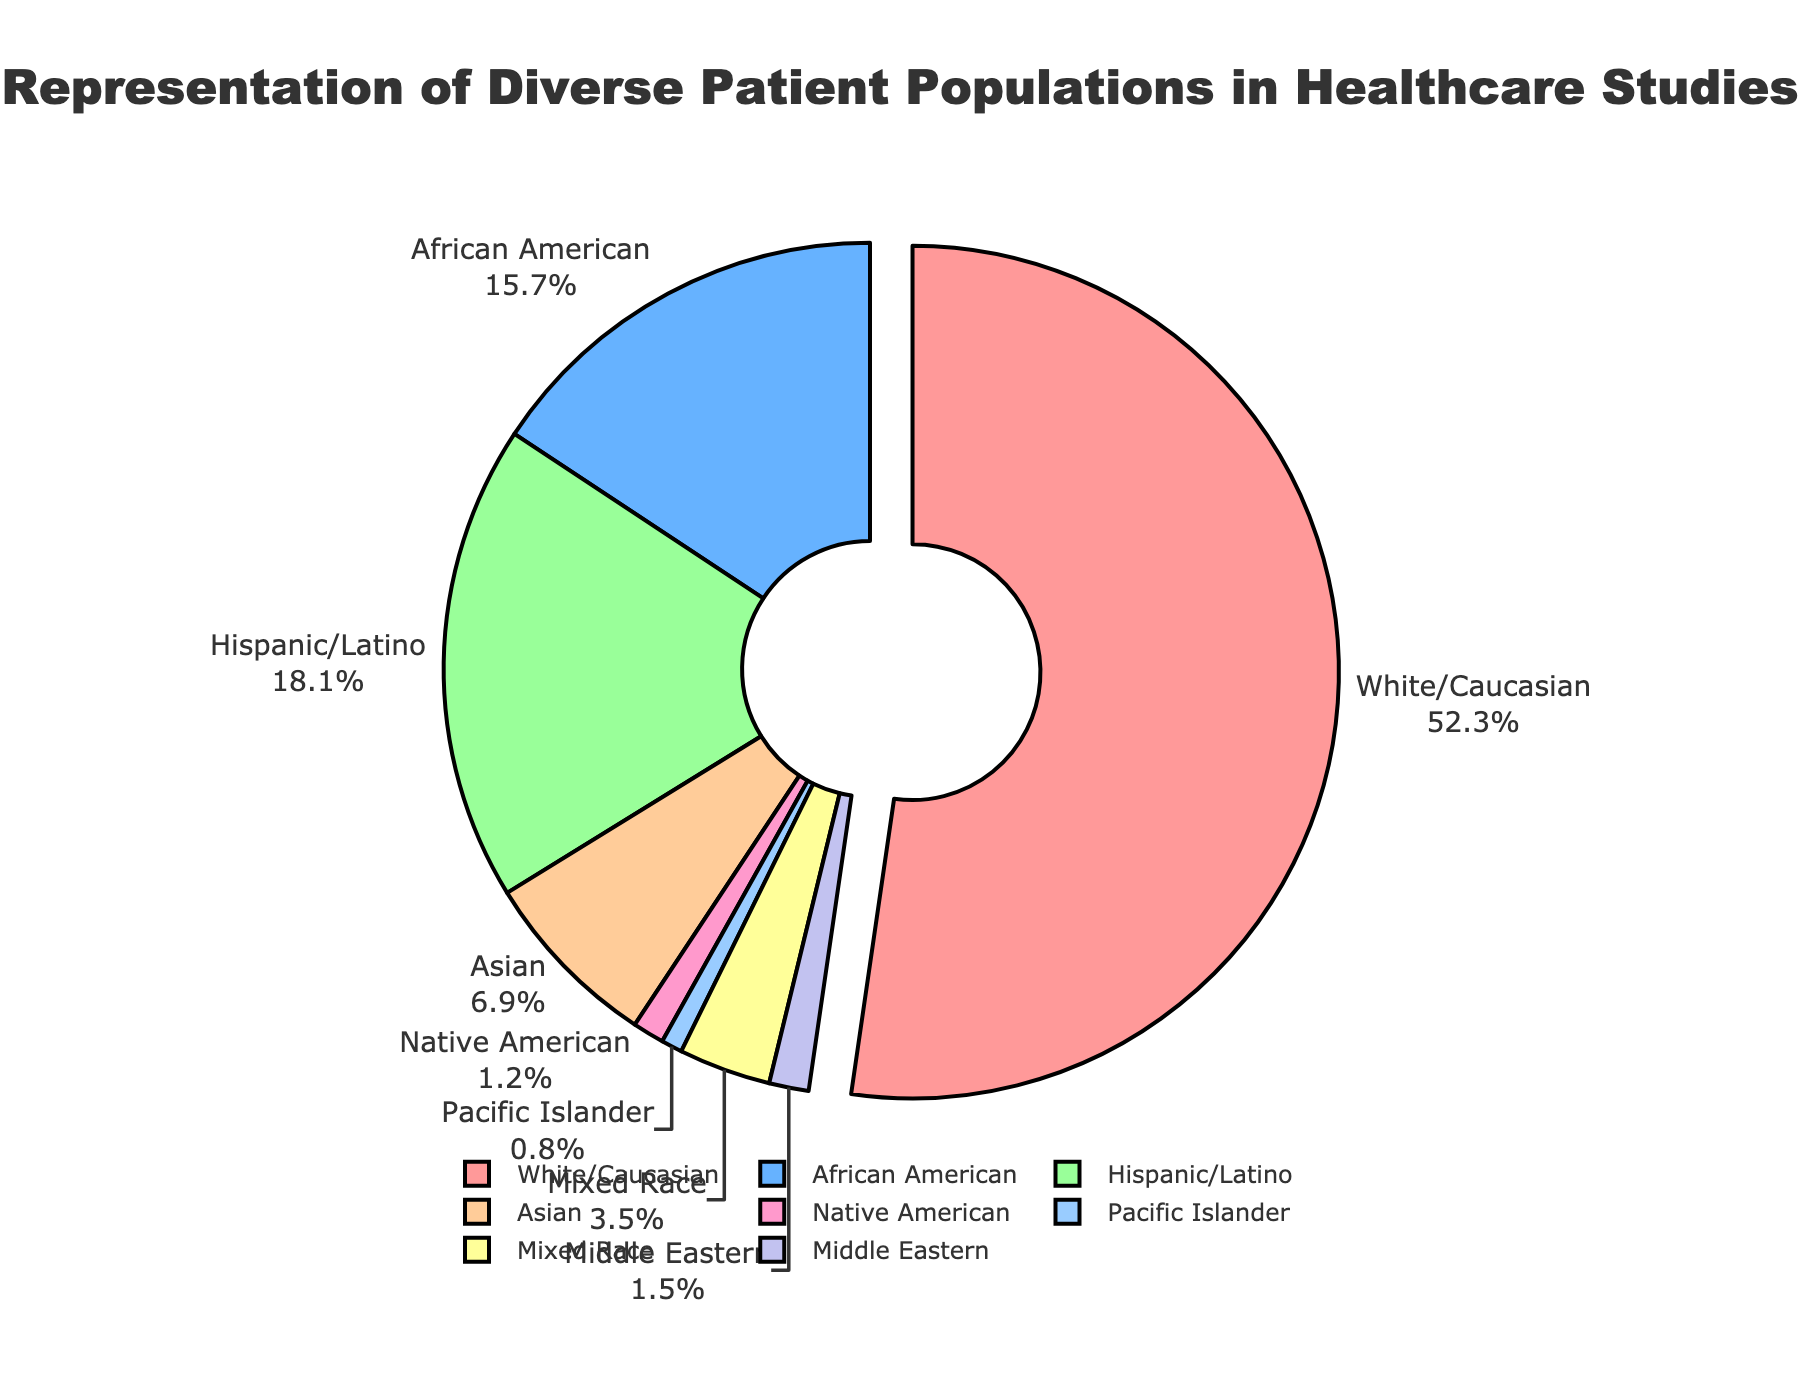What ethnicity has the highest representation in healthcare studies? The ethnicity with the highest percentage in the pie chart is White/Caucasian.
Answer: White/Caucasian What is the combined percentage of Hispanic/Latino and African American populations? The percentages for Hispanic/Latino and African American are 18.1% and 15.7%, respectively. Combined, this is 18.1 + 15.7 = 33.8%.
Answer: 33.8% Which ethnicity has the smallest representation and what is its percentage? The ethnicity with the smallest percentage in the pie chart is Pacific Islander with 0.8%.
Answer: Pacific Islander (0.8%) What is the percentage difference between Whites/Caucasians and Asians? The percentage for Whites/Caucasians is 52.3%, and for Asians, it is 6.9%. The difference is 52.3 - 6.9 = 45.4%.
Answer: 45.4% How many ethnicities have a representation of less than 5%? The ethnicities with representation less than 5% are Native American (1.2%), Pacific Islander (0.8%), Mixed Race (3.5%), and Middle Eastern (1.5%). There are 4 such ethnicities.
Answer: 4 What percentage of the studied populations is made up of Asian, Native American, and Middle Eastern groups combined? The percentages are Asian (6.9%), Native American (1.2%), and Middle Eastern (1.5%). Combined, this is 6.9 + 1.2 + 1.5 = 9.6%.
Answer: 9.6% Which ethnicity’s representation is closest to 20%? The closest representation to 20% is Hispanic/Latino with 18.1%.
Answer: Hispanic/Latino What is the visual color used to represent the Mixed Race population? The color for the Mixed Race population in the pie chart is a light shade of purple.
Answer: Light purple Compare the combined representation of African American and Mixed Race populations to the representation of the White/Caucasian population. Is it greater or lesser? The combined percentage for African American and Mixed Race is 15.7 + 3.5 = 19.2%. The representation of White/Caucasian is 52.3%. Hence, the combined percentage is less than the White/Caucasian percentage.
Answer: Lesser 